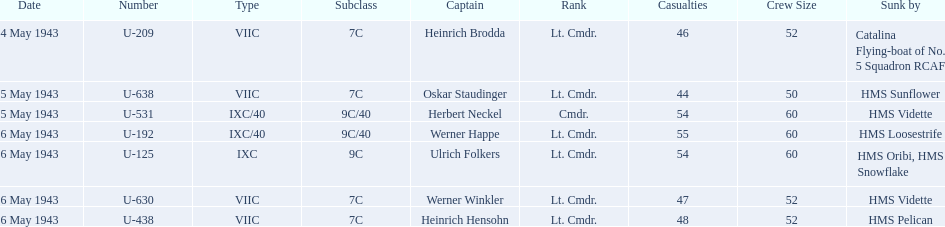Who are all of the captains? Heinrich Brodda, Oskar Staudinger, Herbert Neckel, Werner Happe, Ulrich Folkers, Werner Winkler, Heinrich Hensohn. What sunk each of the captains? Catalina Flying-boat of No. 5 Squadron RCAF, HMS Sunflower, HMS Vidette, HMS Loosestrife, HMS Oribi, HMS Snowflake, HMS Vidette, HMS Pelican. Which was sunk by the hms pelican? Heinrich Hensohn. 